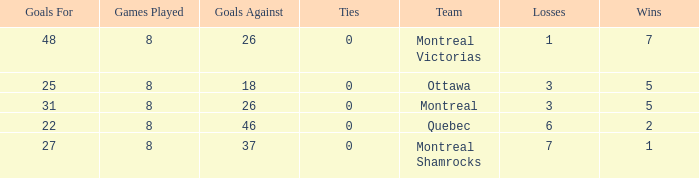For teams with fewer than 5 wins, goals against over 37, and fewer than 8 games played, what is the average number of ties? None. 